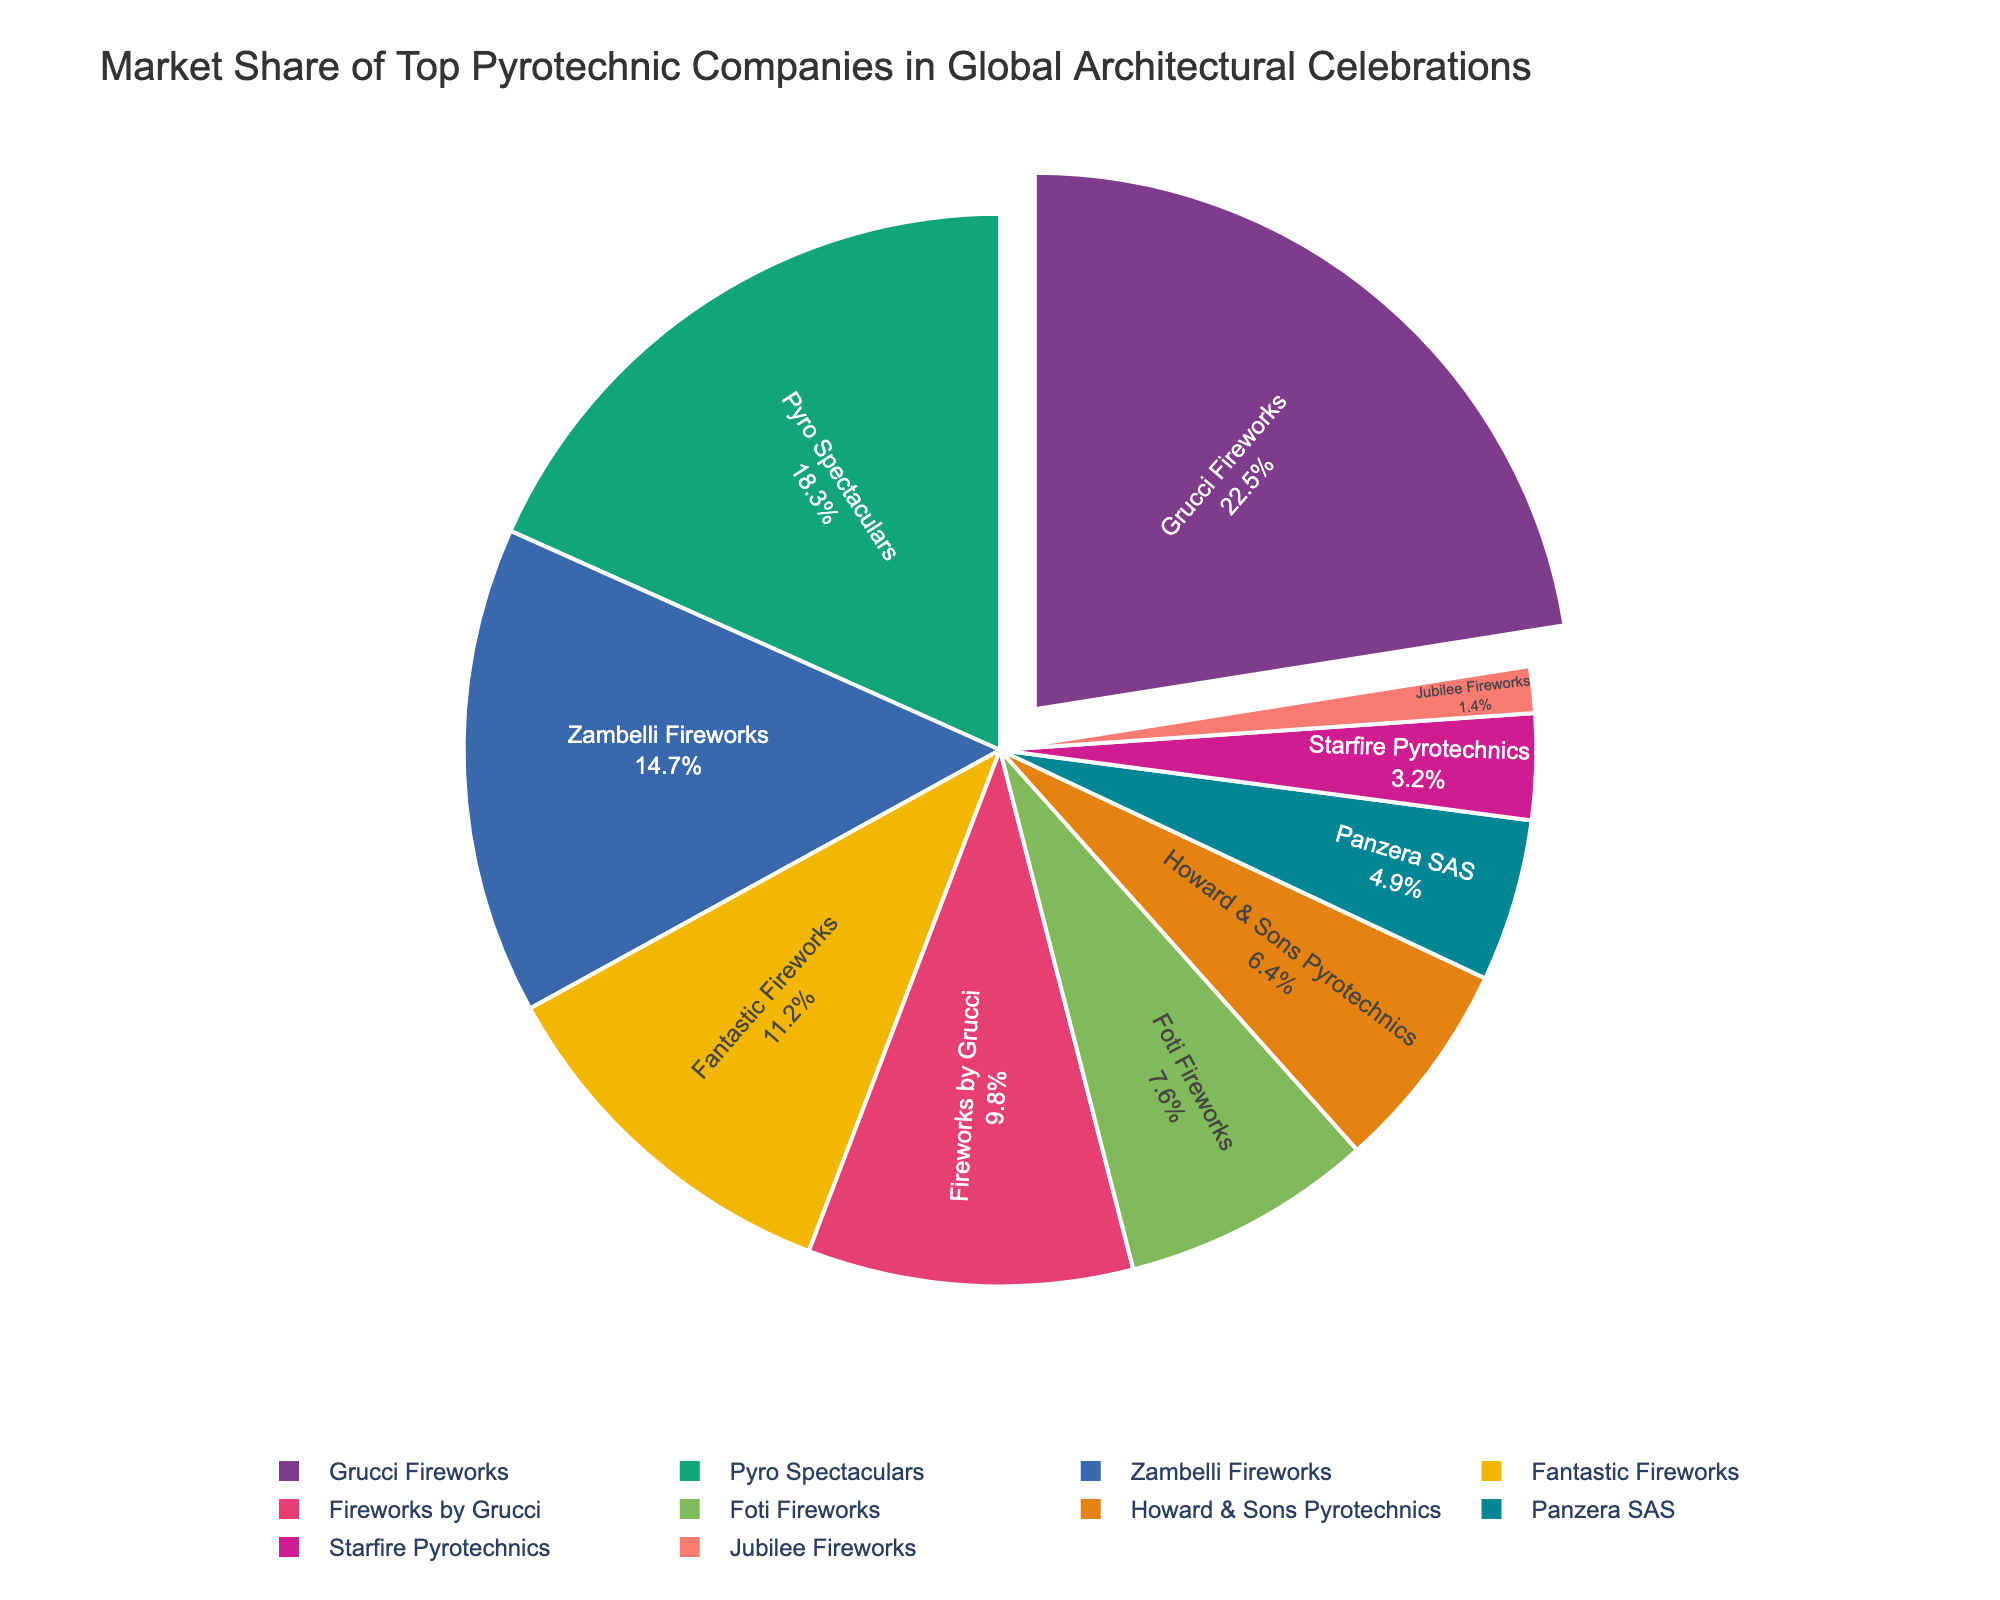What is the market share of Grucci Fireworks? According to the pie chart, Grucci Fireworks has a market share of 22.5%.
Answer: 22.5% Which company has the second-largest market share and what is it? The pie chart shows that Pyro Spectaculars has the second-largest market share with 18.3%.
Answer: Pyro Spectaculars, 18.3% What is the combined market share of Zambelli Fireworks and Fantastic Fireworks? The market share of Zambelli Fireworks is 14.7% and Fantastic Fireworks is 11.2%. Adding them together gives 14.7 + 11.2 = 25.9%.
Answer: 25.9% How does the market share of Fireworks by Grucci compare to that of Foti Fireworks? The market share of Fireworks by Grucci is 9.8% while Foti Fireworks has a market share of 7.6%. Therefore, Fireworks by Grucci's market share is 2.2% higher than that of Foti Fireworks.
Answer: Fireworks by Grucci has 2.2% more Which company has the smallest market share and what is it? The pie chart reveals that Jubilee Fireworks has the smallest market share at 1.4%.
Answer: Jubilee Fireworks, 1.4% What percentage of the market do the companies with shares below 5% hold collectively? The companies with market shares below 5% are Panzera SAS with 4.9% and Starfire Pyrotechnics with 3.2%, and Jubilee Fireworks with 1.4%. Adding these gives 4.9 + 3.2 + 1.4 = 9.5%.
Answer: 9.5% What is the difference in market share between Fantastic Fireworks and Howard & Sons Pyrotechnics? Fantastic Fireworks has a market share of 11.2% while Howard & Sons Pyrotechnics has a market share of 6.4%. The difference is 11.2 - 6.4 = 4.8%.
Answer: 4.8% Which company segment is visually the largest on the pie chart, and why? The visually largest segment on the pie chart is that of Grucci Fireworks due to its highest market share of 22.5%.
Answer: Grucci Fireworks Are there more companies with market shares above or below 10%? From the pie chart, the companies with shares above 10% are Grucci Fireworks, Pyro Spectaculars, Zambelli Fireworks, and Fantastic Fireworks (4 companies). The companies with shares below 10% are Fireworks by Grucci, Foti Fireworks, Howard & Sons Pyrotechnics, Panzera SAS, Starfire Pyrotechnics, and Jubilee Fireworks (6 companies).
Answer: Below 10% What is the average market share of Pyro Spectaculars, Zambelli Fireworks, and Fantastic Fireworks? The market shares are 18.3% (Pyro Spectaculars), 14.7% (Zambelli Fireworks), and 11.2% (Fantastic Fireworks). The average is (18.3 + 14.7 + 11.2) / 3 = 44.2 / 3 = 14.73%.
Answer: 14.73% 